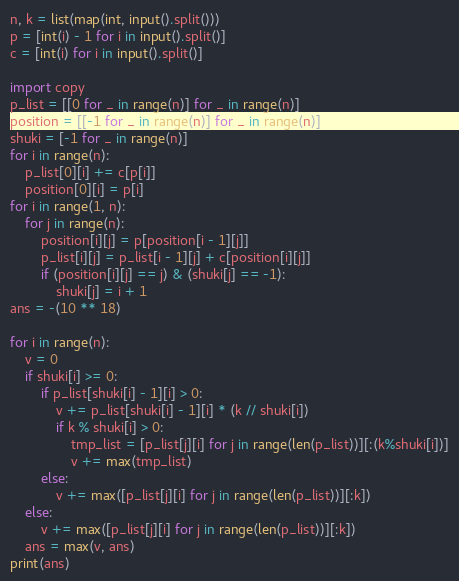Convert code to text. <code><loc_0><loc_0><loc_500><loc_500><_Python_>n, k = list(map(int, input().split()))
p = [int(i) - 1 for i in input().split()]
c = [int(i) for i in input().split()]

import copy
p_list = [[0 for _ in range(n)] for _ in range(n)]
position = [[-1 for _ in range(n)] for _ in range(n)]
shuki = [-1 for _ in range(n)]
for i in range(n):
    p_list[0][i] += c[p[i]]
    position[0][i] = p[i]    
for i in range(1, n):
    for j in range(n):
        position[i][j] = p[position[i - 1][j]]
        p_list[i][j] = p_list[i - 1][j] + c[position[i][j]]        
        if (position[i][j] == j) & (shuki[j] == -1):
            shuki[j] = i + 1
ans = -(10 ** 18)

for i in range(n):    
    v = 0
    if shuki[i] >= 0:
        if p_list[shuki[i] - 1][i] > 0:
            v += p_list[shuki[i] - 1][i] * (k // shuki[i])
            if k % shuki[i] > 0:
                tmp_list = [p_list[j][i] for j in range(len(p_list))][:(k%shuki[i])]
                v += max(tmp_list)
        else:
            v += max([p_list[j][i] for j in range(len(p_list))][:k])
    else:
        v += max([p_list[j][i] for j in range(len(p_list))][:k])
    ans = max(v, ans)
print(ans)</code> 